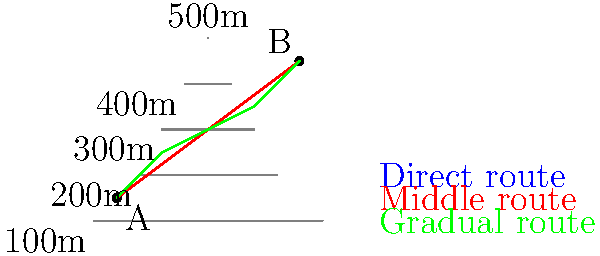As a military nurse planning a medical evacuation, you need to determine the most efficient route from point A to point B on the given topographical map. Which colored path represents the best route for the evacuation team, considering both distance and elevation changes? To determine the most efficient route for medical evacuation, we need to consider both distance and elevation changes. Let's analyze each route:

1. Blue route (direct):
   - Shortest distance
   - Crosses contour lines at sharp angles
   - Involves steep climbs and descents

2. Red route (middle):
   - Slightly longer than the blue route
   - Follows contour lines more closely
   - Moderate elevation changes

3. Green route (gradual):
   - Longest distance
   - Follows contour lines most closely
   - Gentlest elevation changes

For medical evacuation, we need to prioritize:
a) Patient comfort and safety
b) Ease of movement for the evacuation team
c) Time efficiency

The green route, while longest, offers the most gradual elevation changes. This is crucial for:
- Maintaining patient stability
- Reducing strain on the evacuation team
- Allowing for consistent movement speed

The red route is a compromise between distance and elevation change but still involves more abrupt changes than the green route.

The blue route, while shortest, involves steep climbs and descents, which could:
- Potentially harm the patient
- Exhaust the evacuation team
- Slow down overall progress due to difficult terrain

Therefore, the green route represents the best balance of patient safety, team efficiency, and overall evacuation speed, despite being the longest in terms of distance.
Answer: Green route 